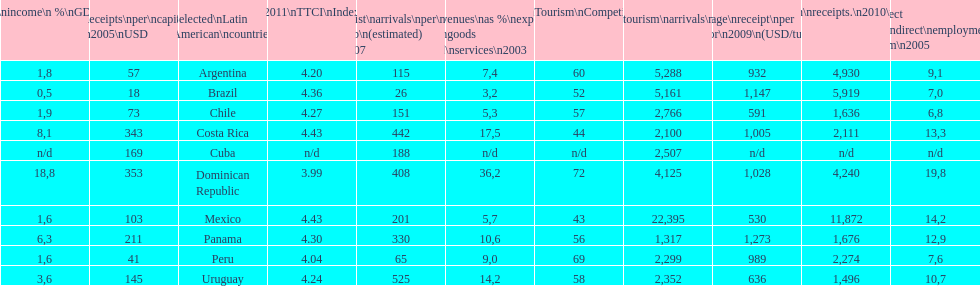What country had the most receipts per capita in 2005? Dominican Republic. 